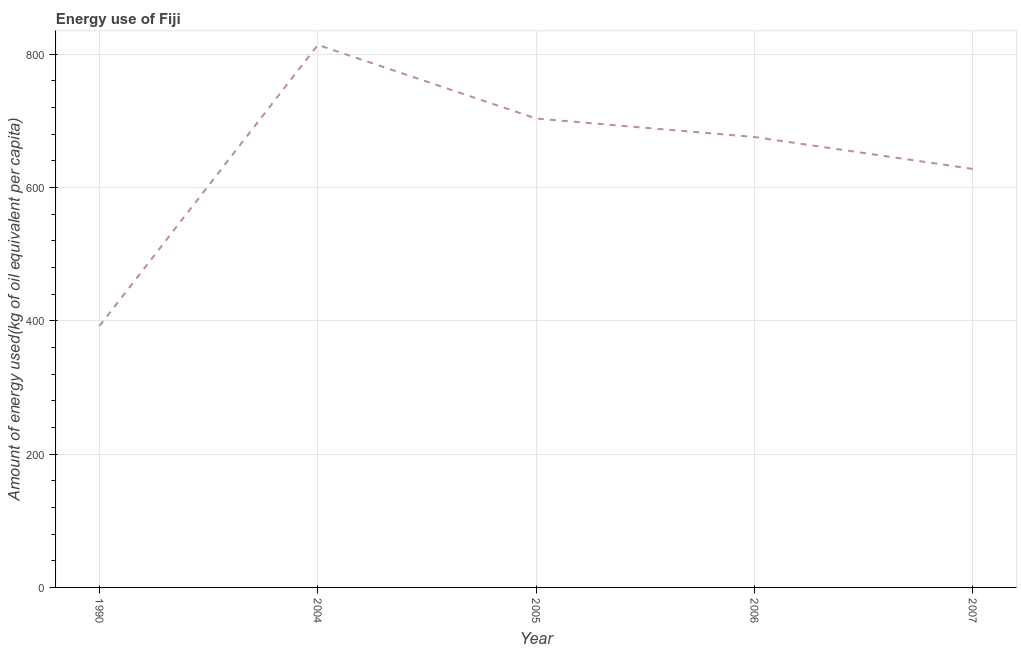What is the amount of energy used in 2005?
Give a very brief answer. 703.32. Across all years, what is the maximum amount of energy used?
Offer a very short reply. 813.83. Across all years, what is the minimum amount of energy used?
Offer a terse response. 392.25. In which year was the amount of energy used minimum?
Keep it short and to the point. 1990. What is the sum of the amount of energy used?
Give a very brief answer. 3212.77. What is the difference between the amount of energy used in 2004 and 2005?
Your response must be concise. 110.51. What is the average amount of energy used per year?
Provide a succinct answer. 642.55. What is the median amount of energy used?
Your response must be concise. 675.62. What is the ratio of the amount of energy used in 2005 to that in 2006?
Your answer should be very brief. 1.04. What is the difference between the highest and the second highest amount of energy used?
Your answer should be compact. 110.51. Is the sum of the amount of energy used in 1990 and 2005 greater than the maximum amount of energy used across all years?
Your answer should be compact. Yes. What is the difference between the highest and the lowest amount of energy used?
Your response must be concise. 421.57. Does the amount of energy used monotonically increase over the years?
Your answer should be very brief. No. How many lines are there?
Your answer should be compact. 1. Does the graph contain any zero values?
Offer a terse response. No. Does the graph contain grids?
Your answer should be compact. Yes. What is the title of the graph?
Ensure brevity in your answer.  Energy use of Fiji. What is the label or title of the Y-axis?
Provide a short and direct response. Amount of energy used(kg of oil equivalent per capita). What is the Amount of energy used(kg of oil equivalent per capita) in 1990?
Your response must be concise. 392.25. What is the Amount of energy used(kg of oil equivalent per capita) of 2004?
Your answer should be compact. 813.83. What is the Amount of energy used(kg of oil equivalent per capita) in 2005?
Provide a succinct answer. 703.32. What is the Amount of energy used(kg of oil equivalent per capita) in 2006?
Your answer should be very brief. 675.62. What is the Amount of energy used(kg of oil equivalent per capita) of 2007?
Provide a short and direct response. 627.75. What is the difference between the Amount of energy used(kg of oil equivalent per capita) in 1990 and 2004?
Keep it short and to the point. -421.57. What is the difference between the Amount of energy used(kg of oil equivalent per capita) in 1990 and 2005?
Offer a terse response. -311.06. What is the difference between the Amount of energy used(kg of oil equivalent per capita) in 1990 and 2006?
Offer a terse response. -283.36. What is the difference between the Amount of energy used(kg of oil equivalent per capita) in 1990 and 2007?
Offer a very short reply. -235.5. What is the difference between the Amount of energy used(kg of oil equivalent per capita) in 2004 and 2005?
Your answer should be very brief. 110.51. What is the difference between the Amount of energy used(kg of oil equivalent per capita) in 2004 and 2006?
Provide a short and direct response. 138.21. What is the difference between the Amount of energy used(kg of oil equivalent per capita) in 2004 and 2007?
Offer a very short reply. 186.08. What is the difference between the Amount of energy used(kg of oil equivalent per capita) in 2005 and 2006?
Keep it short and to the point. 27.7. What is the difference between the Amount of energy used(kg of oil equivalent per capita) in 2005 and 2007?
Give a very brief answer. 75.57. What is the difference between the Amount of energy used(kg of oil equivalent per capita) in 2006 and 2007?
Provide a short and direct response. 47.87. What is the ratio of the Amount of energy used(kg of oil equivalent per capita) in 1990 to that in 2004?
Keep it short and to the point. 0.48. What is the ratio of the Amount of energy used(kg of oil equivalent per capita) in 1990 to that in 2005?
Offer a terse response. 0.56. What is the ratio of the Amount of energy used(kg of oil equivalent per capita) in 1990 to that in 2006?
Ensure brevity in your answer.  0.58. What is the ratio of the Amount of energy used(kg of oil equivalent per capita) in 1990 to that in 2007?
Offer a terse response. 0.62. What is the ratio of the Amount of energy used(kg of oil equivalent per capita) in 2004 to that in 2005?
Provide a succinct answer. 1.16. What is the ratio of the Amount of energy used(kg of oil equivalent per capita) in 2004 to that in 2006?
Your answer should be compact. 1.21. What is the ratio of the Amount of energy used(kg of oil equivalent per capita) in 2004 to that in 2007?
Offer a terse response. 1.3. What is the ratio of the Amount of energy used(kg of oil equivalent per capita) in 2005 to that in 2006?
Ensure brevity in your answer.  1.04. What is the ratio of the Amount of energy used(kg of oil equivalent per capita) in 2005 to that in 2007?
Provide a short and direct response. 1.12. What is the ratio of the Amount of energy used(kg of oil equivalent per capita) in 2006 to that in 2007?
Give a very brief answer. 1.08. 